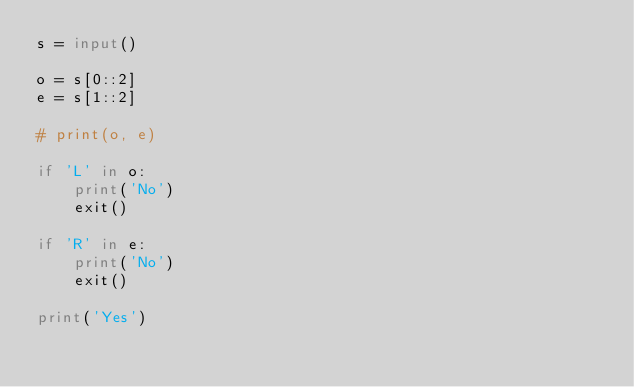<code> <loc_0><loc_0><loc_500><loc_500><_Python_>s = input()

o = s[0::2]
e = s[1::2]

# print(o, e)

if 'L' in o:
    print('No')
    exit()

if 'R' in e:
    print('No')
    exit()

print('Yes')</code> 